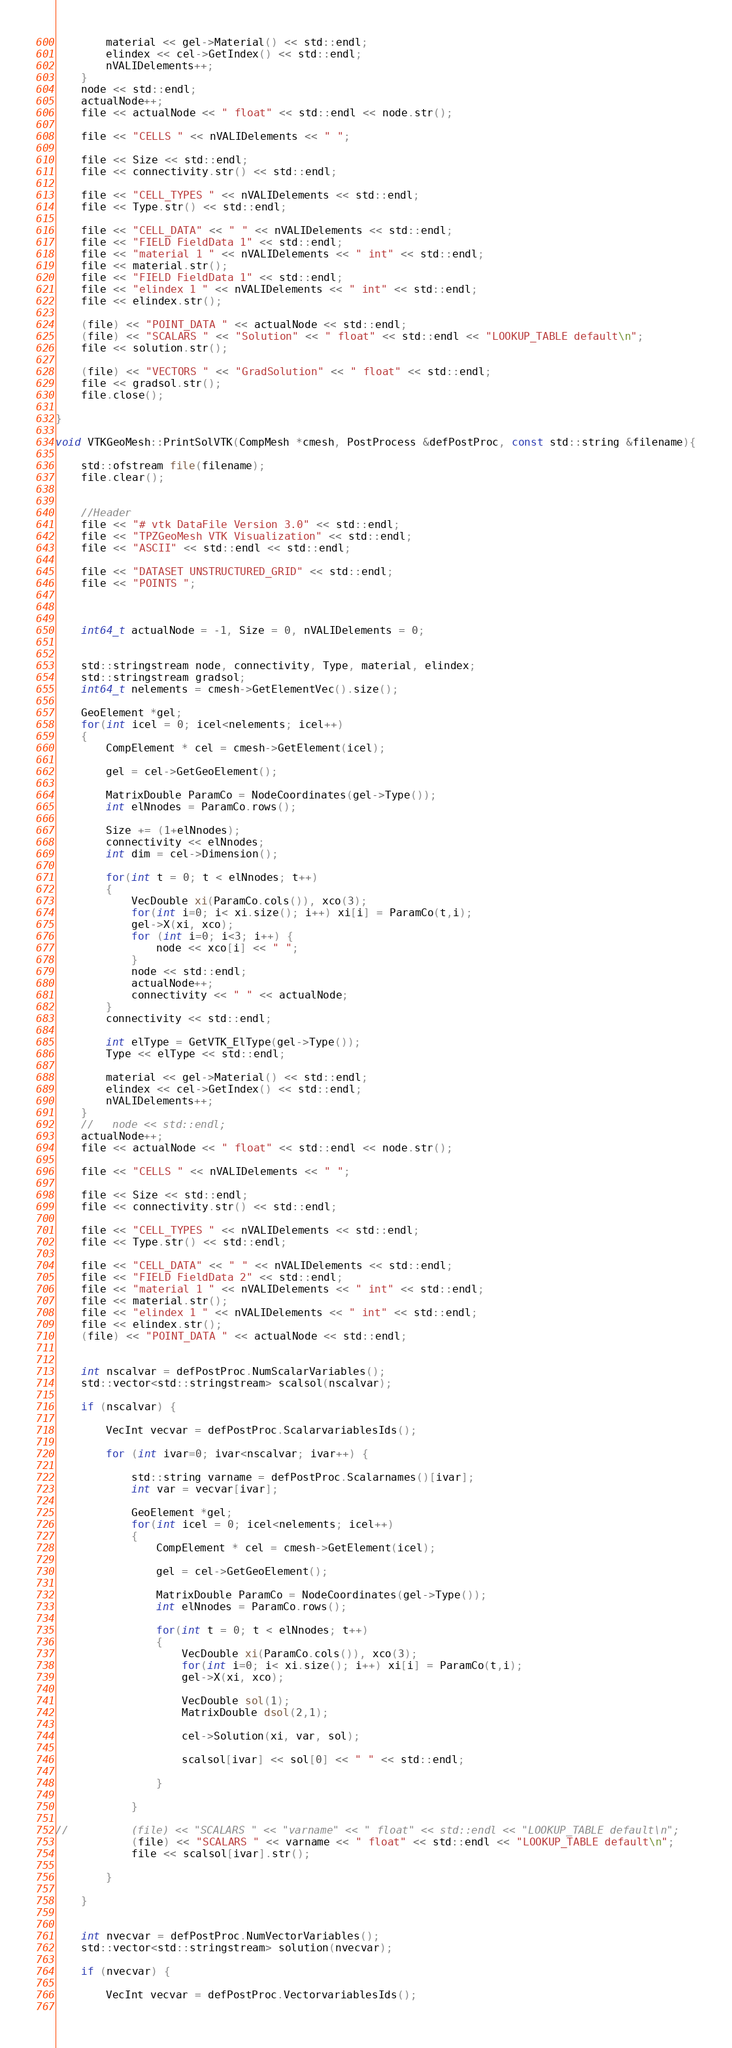Convert code to text. <code><loc_0><loc_0><loc_500><loc_500><_C++_>        material << gel->Material() << std::endl;
        elindex << cel->GetIndex() << std::endl;
        nVALIDelements++;
    }
    node << std::endl;
    actualNode++;
    file << actualNode << " float" << std::endl << node.str();
    
    file << "CELLS " << nVALIDelements << " ";
    
    file << Size << std::endl;
    file << connectivity.str() << std::endl;
    
    file << "CELL_TYPES " << nVALIDelements << std::endl;
    file << Type.str() << std::endl;
    
    file << "CELL_DATA" << " " << nVALIDelements << std::endl;
    file << "FIELD FieldData 1" << std::endl;
    file << "material 1 " << nVALIDelements << " int" << std::endl;
    file << material.str();
    file << "FIELD FieldData 1" << std::endl;
    file << "elindex 1 " << nVALIDelements << " int" << std::endl;
    file << elindex.str();
    
    (file) << "POINT_DATA " << actualNode << std::endl;
    (file) << "SCALARS " << "Solution" << " float" << std::endl << "LOOKUP_TABLE default\n";
    file << solution.str();
    
    (file) << "VECTORS " << "GradSolution" << " float" << std::endl;
    file << gradsol.str();
    file.close();

}

void VTKGeoMesh::PrintSolVTK(CompMesh *cmesh, PostProcess &defPostProc, const std::string &filename){

    std::ofstream file(filename);
    file.clear();
    
    
    //Header
    file << "# vtk DataFile Version 3.0" << std::endl;
    file << "TPZGeoMesh VTK Visualization" << std::endl;
    file << "ASCII" << std::endl << std::endl;
    
    file << "DATASET UNSTRUCTURED_GRID" << std::endl;
    file << "POINTS ";
    

    
    int64_t actualNode = -1, Size = 0, nVALIDelements = 0;
    
    
    std::stringstream node, connectivity, Type, material, elindex;
    std::stringstream gradsol;
    int64_t nelements = cmesh->GetElementVec().size();
    
    GeoElement *gel;
    for(int icel = 0; icel<nelements; icel++)
    {
        CompElement * cel = cmesh->GetElement(icel);
        
        gel = cel->GetGeoElement();
        
        MatrixDouble ParamCo = NodeCoordinates(gel->Type());
        int elNnodes = ParamCo.rows();
        
        Size += (1+elNnodes);
        connectivity << elNnodes;
        int dim = cel->Dimension();
        
        for(int t = 0; t < elNnodes; t++)
        {
            VecDouble xi(ParamCo.cols()), xco(3);
            for(int i=0; i< xi.size(); i++) xi[i] = ParamCo(t,i);
            gel->X(xi, xco);
            for (int i=0; i<3; i++) {
                node << xco[i] << " ";
            }
            node << std::endl;
            actualNode++;
            connectivity << " " << actualNode;
        }
        connectivity << std::endl;
        
        int elType = GetVTK_ElType(gel->Type());
        Type << elType << std::endl;
        
        material << gel->Material() << std::endl;
        elindex << cel->GetIndex() << std::endl;
        nVALIDelements++;
    }
    //   node << std::endl;
    actualNode++;
    file << actualNode << " float" << std::endl << node.str();
    
    file << "CELLS " << nVALIDelements << " ";
    
    file << Size << std::endl;
    file << connectivity.str() << std::endl;
    
    file << "CELL_TYPES " << nVALIDelements << std::endl;
    file << Type.str() << std::endl;
    
    file << "CELL_DATA" << " " << nVALIDelements << std::endl;
    file << "FIELD FieldData 2" << std::endl;
    file << "material 1 " << nVALIDelements << " int" << std::endl;
    file << material.str();
    file << "elindex 1 " << nVALIDelements << " int" << std::endl;
    file << elindex.str();
    (file) << "POINT_DATA " << actualNode << std::endl;
    
    
    int nscalvar = defPostProc.NumScalarVariables();
    std::vector<std::stringstream> scalsol(nscalvar);
    
    if (nscalvar) {
        
        VecInt vecvar = defPostProc.ScalarvariablesIds();
        
        for (int ivar=0; ivar<nscalvar; ivar++) {
            
            std::string varname = defPostProc.Scalarnames()[ivar];
            int var = vecvar[ivar];
            
            GeoElement *gel;
            for(int icel = 0; icel<nelements; icel++)
            {
                CompElement * cel = cmesh->GetElement(icel);
                
                gel = cel->GetGeoElement();
                
                MatrixDouble ParamCo = NodeCoordinates(gel->Type());
                int elNnodes = ParamCo.rows();
                
                for(int t = 0; t < elNnodes; t++)
                {
                    VecDouble xi(ParamCo.cols()), xco(3);
                    for(int i=0; i< xi.size(); i++) xi[i] = ParamCo(t,i);
                    gel->X(xi, xco);
                    
                    VecDouble sol(1);
                    MatrixDouble dsol(2,1);
                    
                    cel->Solution(xi, var, sol);
                    
                    scalsol[ivar] << sol[0] << " " << std::endl;
                    
                }
                
            }
            
//          (file) << "SCALARS " << "varname" << " float" << std::endl << "LOOKUP_TABLE default\n";
            (file) << "SCALARS " << varname << " float" << std::endl << "LOOKUP_TABLE default\n";
            file << scalsol[ivar].str();
            
        }
        
    }
    
    
    int nvecvar = defPostProc.NumVectorVariables();
    std::vector<std::stringstream> solution(nvecvar);
    
    if (nvecvar) {
        
        VecInt vecvar = defPostProc.VectorvariablesIds();
       </code> 